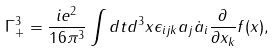<formula> <loc_0><loc_0><loc_500><loc_500>\Gamma _ { + } ^ { 3 } = \frac { i e ^ { 2 } } { 1 6 \pi ^ { 3 } } \int d t d ^ { 3 } { x } \epsilon _ { i j k } a _ { j } \dot { a } _ { i } \frac { \partial } { \partial x _ { k } } f ( { x } ) ,</formula> 